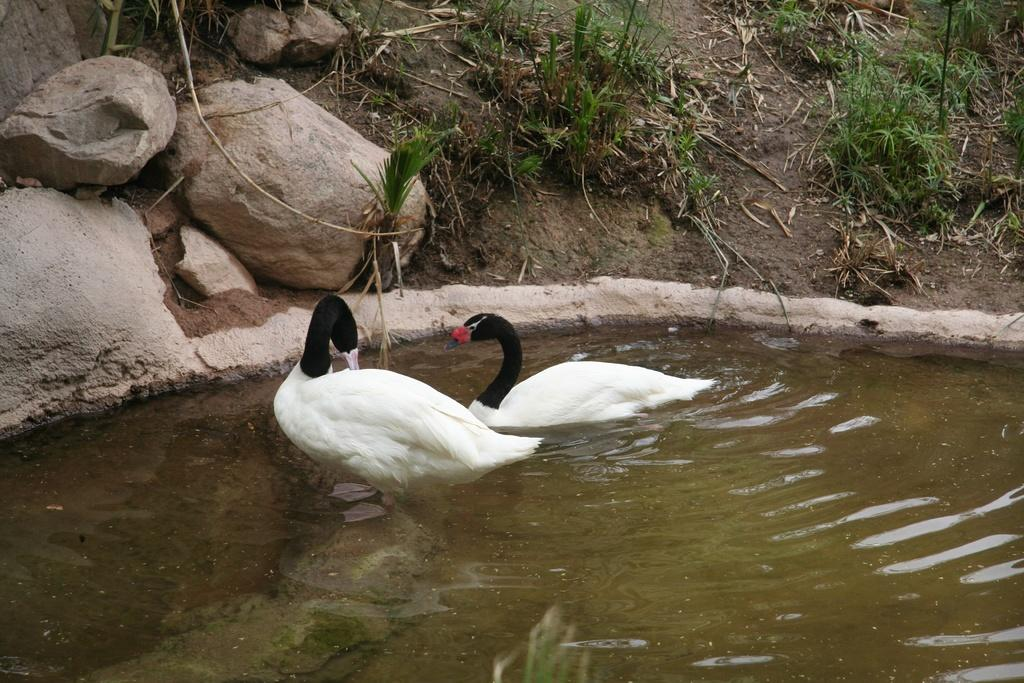What animals can be seen in the image? There are two swans in the image. What are the swans doing in the image? The swans are swimming in a pond. What other elements can be seen in the image besides the swans? There are rocks visible in the image. What type of vegetation is present on the land in the image? There is grass on the land in the image. How many fingers can be seen on the swans in the image? Swans do not have fingers, so none can be seen on them in the image. 